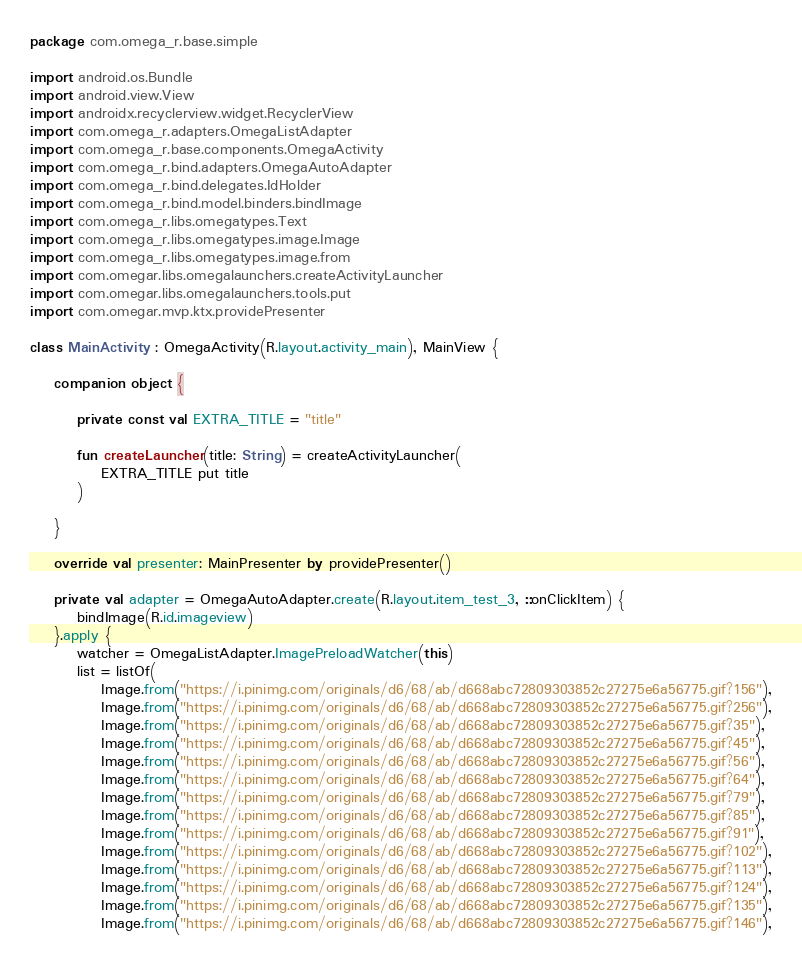Convert code to text. <code><loc_0><loc_0><loc_500><loc_500><_Kotlin_>package com.omega_r.base.simple

import android.os.Bundle
import android.view.View
import androidx.recyclerview.widget.RecyclerView
import com.omega_r.adapters.OmegaListAdapter
import com.omega_r.base.components.OmegaActivity
import com.omega_r.bind.adapters.OmegaAutoAdapter
import com.omega_r.bind.delegates.IdHolder
import com.omega_r.bind.model.binders.bindImage
import com.omega_r.libs.omegatypes.Text
import com.omega_r.libs.omegatypes.image.Image
import com.omega_r.libs.omegatypes.image.from
import com.omegar.libs.omegalaunchers.createActivityLauncher
import com.omegar.libs.omegalaunchers.tools.put
import com.omegar.mvp.ktx.providePresenter

class MainActivity : OmegaActivity(R.layout.activity_main), MainView {

    companion object {

        private const val EXTRA_TITLE = "title"

        fun createLauncher(title: String) = createActivityLauncher(
            EXTRA_TITLE put title
        )

    }

    override val presenter: MainPresenter by providePresenter()

    private val adapter = OmegaAutoAdapter.create(R.layout.item_test_3, ::onClickItem) {
        bindImage(R.id.imageview)
    }.apply {
        watcher = OmegaListAdapter.ImagePreloadWatcher(this)
        list = listOf(
            Image.from("https://i.pinimg.com/originals/d6/68/ab/d668abc72809303852c27275e6a56775.gif?156"),
            Image.from("https://i.pinimg.com/originals/d6/68/ab/d668abc72809303852c27275e6a56775.gif?256"),
            Image.from("https://i.pinimg.com/originals/d6/68/ab/d668abc72809303852c27275e6a56775.gif?35"),
            Image.from("https://i.pinimg.com/originals/d6/68/ab/d668abc72809303852c27275e6a56775.gif?45"),
            Image.from("https://i.pinimg.com/originals/d6/68/ab/d668abc72809303852c27275e6a56775.gif?56"),
            Image.from("https://i.pinimg.com/originals/d6/68/ab/d668abc72809303852c27275e6a56775.gif?64"),
            Image.from("https://i.pinimg.com/originals/d6/68/ab/d668abc72809303852c27275e6a56775.gif?79"),
            Image.from("https://i.pinimg.com/originals/d6/68/ab/d668abc72809303852c27275e6a56775.gif?85"),
            Image.from("https://i.pinimg.com/originals/d6/68/ab/d668abc72809303852c27275e6a56775.gif?91"),
            Image.from("https://i.pinimg.com/originals/d6/68/ab/d668abc72809303852c27275e6a56775.gif?102"),
            Image.from("https://i.pinimg.com/originals/d6/68/ab/d668abc72809303852c27275e6a56775.gif?113"),
            Image.from("https://i.pinimg.com/originals/d6/68/ab/d668abc72809303852c27275e6a56775.gif?124"),
            Image.from("https://i.pinimg.com/originals/d6/68/ab/d668abc72809303852c27275e6a56775.gif?135"),
            Image.from("https://i.pinimg.com/originals/d6/68/ab/d668abc72809303852c27275e6a56775.gif?146"),</code> 